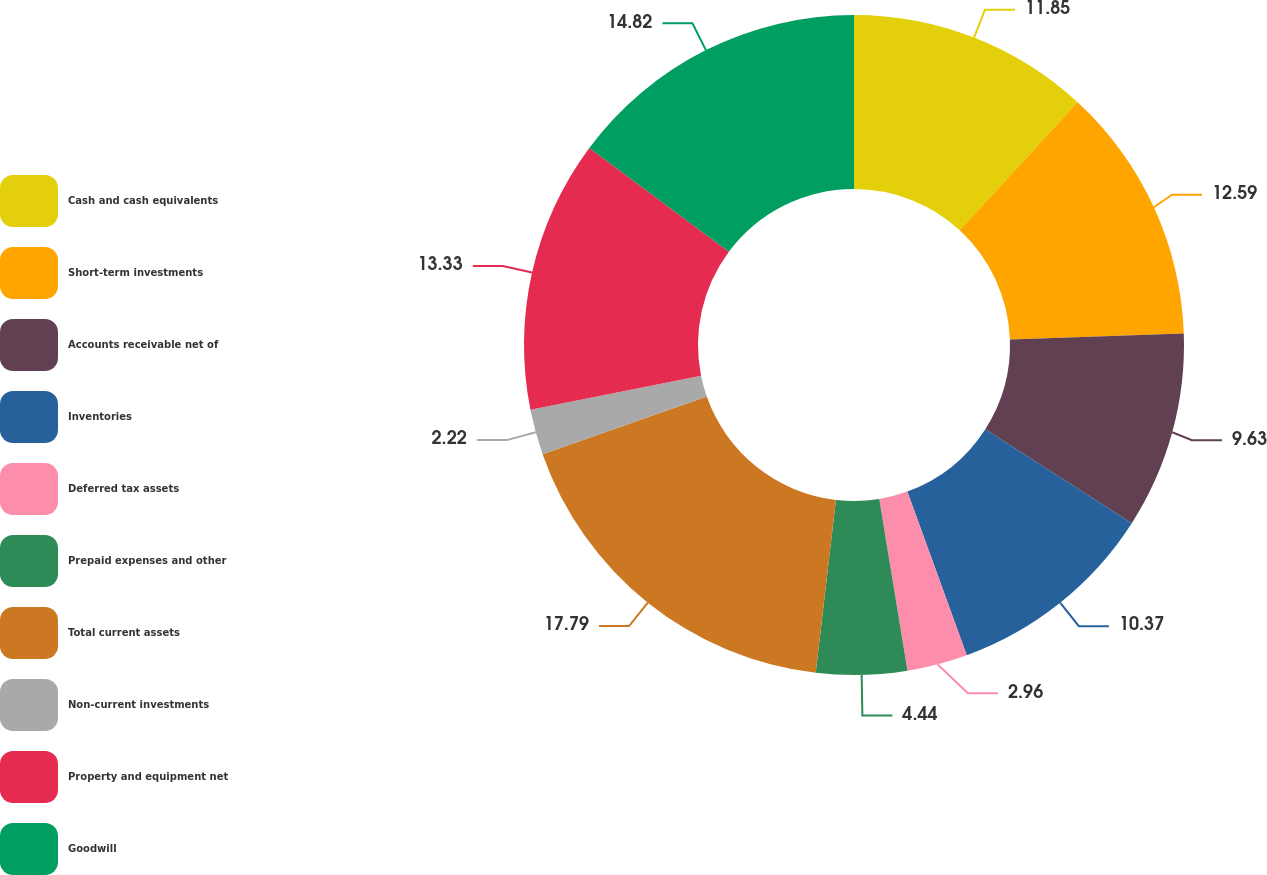Convert chart to OTSL. <chart><loc_0><loc_0><loc_500><loc_500><pie_chart><fcel>Cash and cash equivalents<fcel>Short-term investments<fcel>Accounts receivable net of<fcel>Inventories<fcel>Deferred tax assets<fcel>Prepaid expenses and other<fcel>Total current assets<fcel>Non-current investments<fcel>Property and equipment net<fcel>Goodwill<nl><fcel>11.85%<fcel>12.59%<fcel>9.63%<fcel>10.37%<fcel>2.96%<fcel>4.44%<fcel>17.78%<fcel>2.22%<fcel>13.33%<fcel>14.81%<nl></chart> 